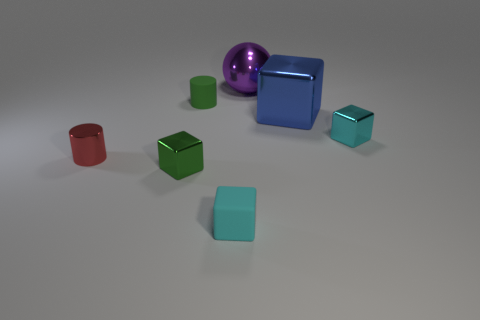Which objects in the image seem to have a reflective surface? The sphere and the two large cubes exhibit highly reflective surfaces, likely indicating they are made of a polished metal or a similar reflective material. 